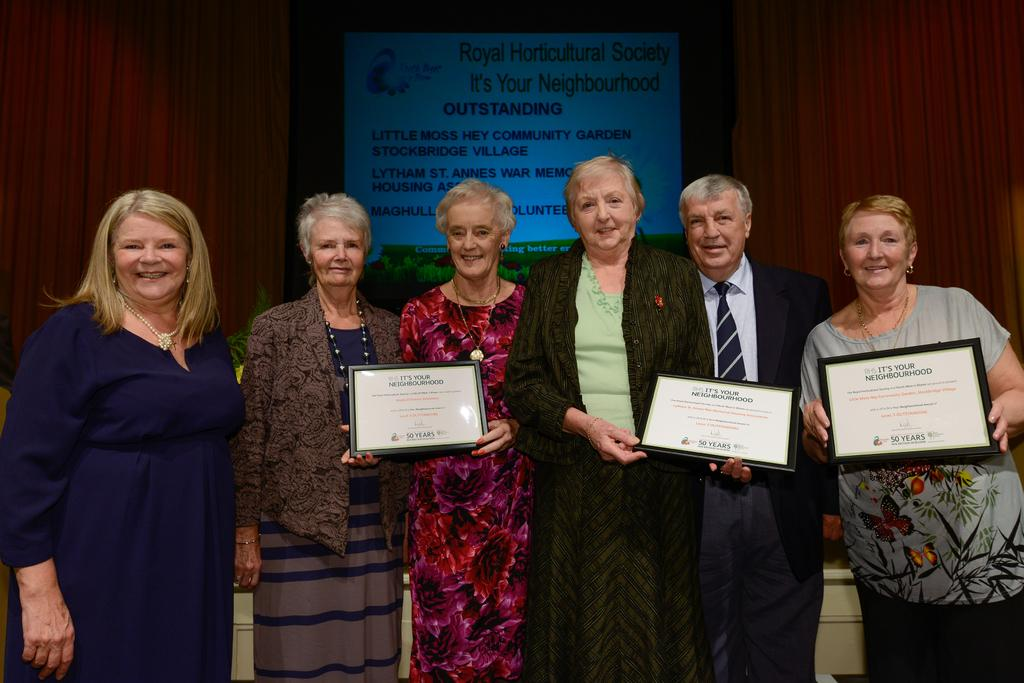What are the people in the image doing? There are people standing in the image. What are some of the people holding? Some people are holding frames. How can you describe the clothing of the people in the image? The people are wearing different color dresses. What can be seen in the background of the image? There is a screen and a brown color curtain visible in the background. Are the people in the image wearing hats? There is no mention of hats in the image, so we cannot determine if the people are wearing hats or not. What type of amusement can be seen in the image? There is no amusement activity or object present in the image. 